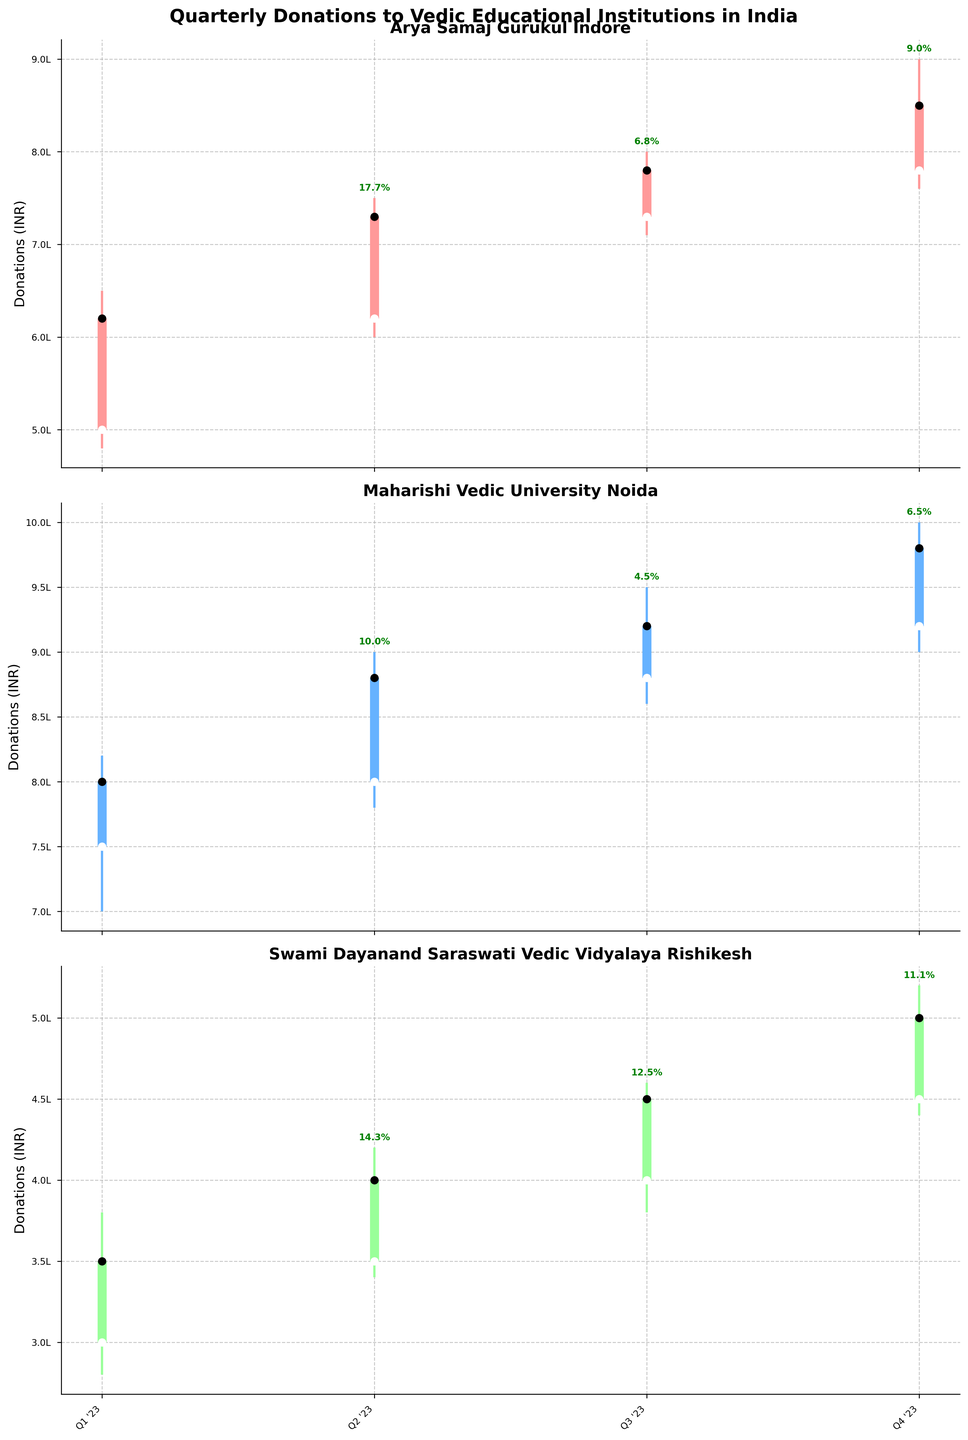What is the title of the figure? The title of the figure is typically displayed at the top of the chart. In this case, it reads "Quarterly Donations to Vedic Educational Institutions in India."
Answer: Quarterly Donations to Vedic Educational Institutions in India How many institutions are displayed in the figure? The figure contains three subplots, each titled with the name of an institution. These are Arya Samaj Gurukul Indore, Maharishi Vedic University Noida, and Swami Dayanand Saraswati Vedic Vidyalaya Rishikesh.
Answer: 3 Which institution had the highest donation in any single quarter? To find the highest donation, we look at the 'High' values across all subplots. Maharishi Vedic University Noida had the highest donation in Q4 2023 with a value of 1,000,000 INR.
Answer: Maharishi Vedic University Noida What was the percentage change in donations from Q3 to Q4 for Arya Samaj Gurukul Indore? According to the figure, the final donations for Arya Samaj Gurukul Indore in Q3 and Q4 were 780,000 INR and 850,000 INR respectively. The percentage change can be calculated as \[((850,000 - 780,000) / 780,000) * 100\], which is approximately 9%.
Answer: 9% Compare the donations for Maharishi Vedic University Noida and Swami Dayanand Saraswati Vedic Vidyalaya Rishikesh in Q4 2023. Which institution had higher donations and by how much? Maharishi Vedic University Noida had close donations of 980,000 INR in Q4, while Swami Dayanand Saraswati Vedic Vidyalaya Rishikesh had 500,000 INR. The difference in donations is 980,000 - 500,000 = 480,000 INR.
Answer: Maharishi Vedic University Noida by 480,000 INR Which institution had the lowest donation in any of the quarters? We check the 'Low' values for the lowest donation across all quarters. Swami Dayanand Saraswati Vedic Vidyalaya Rishikesh had the lowest donation of 280,000 INR in Q1 2023.
Answer: Swami Dayanand Saraswati Vedic Vidyalaya Rishikesh How did the donations for Arya Samaj Gurukul Indore change from Q1 2023 to Q4 2023? To understand the change, we look at the 'Open' value in Q1 2023 (500,000 INR) and the 'Close' value in Q4 2023 (850,000 INR). The increase is 850,000 - 500,000 = 350,000 INR.
Answer: Increased by 350,000 INR What is the average of the quarterly close donations for Swami Dayanand Saraswati Vedic Vidyalaya Rishikesh in 2023? The close donations for each quarter are 350,000 INR, 400,000 INR, 450,000 INR, and 500,000 INR. The average is calculated as \((350,000 + 400,000 + 450,000 + 500,000) / 4 = 425,000\) INR.
Answer: 425,000 INR Which institution had the highest increase in donations from the start to the end of 2023? For each institution, we find the difference between the 'Open' in Q1 and 'Close' in Q4:
- Arya Samaj Gurukul Indore: \(850,000 - 500,000 = 350,000\)
- Maharishi Vedic University Noida: \(980,000 - 750,000 = 230,000\)
- Swami Dayanand Saraswati Vedic Vidyalaya Rishikesh: \(500,000 - 300,000 = 200,000\)
Arya Samaj Gurukul Indore had the highest increase.
Answer: Arya Samaj Gurukul Indore 